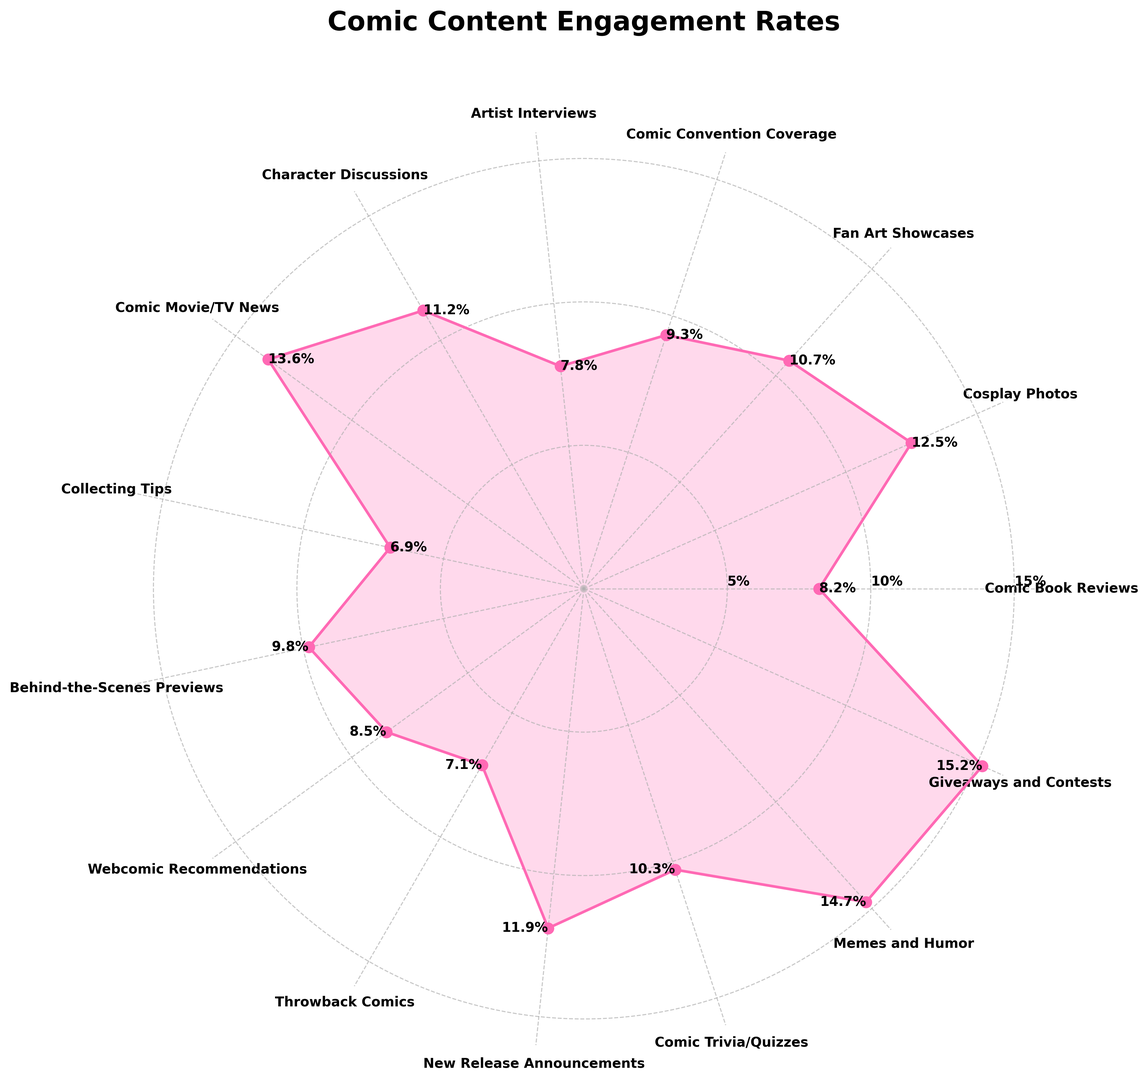Which type of comic-related content has the highest engagement rate? The figure shows various engagement rates, and the largest value on the plot represents the highest engagement rate. In this case, the "Giveaways and Contests" section extends furthest outward, indicating the highest rate.
Answer: Giveaways and Contests What is the difference in engagement rates between Memes and Humor and New Release Announcements? To find the difference, locate the engagement rates for "Memes and Humor" (14.7%) and "New Release Announcements" (11.9%) from the figure and subtract the latter from the former: 14.7% - 11.9% = 2.8%
Answer: 2.8% Which content type has the lowest engagement rate, and what is that rate? By examining the radial lengths on the plot, "Collecting Tips" is the shortest, which indicates the lowest engagement rate of 6.9%.
Answer: Collecting Tips, 6.9% How many content types have an engagement rate above 10%? Check each content type's engagement rate and count those above 10%. "Cosplay Photos," "Character Discussions," "Comic Movie/TV News," "New Release Announcements," "Comic Trivia/Quizzes," "Memes and Humor," and "Giveaways and Contests" have engagement rates above 10%.
Answer: 7 What is the total engagement rate for Fan Art Showcases, Comic Convention Coverage, and Behind-the-Scenes Previews? Sum the engagement rates for "Fan Art Showcases" (10.7%), "Comic Convention Coverage" (9.3%), and "Behind-the-Scenes Previews" (9.8%): 10.7% + 9.3% + 9.8% = 29.8%
Answer: 29.8% What is the average engagement rate for Character Discussions and Comic Movie/TV News? Find the engagement rates for "Character Discussions" (11.2%) and "Comic Movie/TV News" (13.6%), then calculate their average: (11.2% + 13.6%)/2 = 12.4%
Answer: 12.4% Are there more content types with engagement rates above 8% or below 8%? Count the number of content types with rates above 8% and those below 8%. "Comic Book Reviews," "Cosplay Photos," "Fan Art Showcases," "Comic Convention Coverage," "Character Discussions," "Comic Movie/TV News," "Behind-the-Scenes Previews," "Webcomic Recommendations," "New Release Announcements," "Comic Trivia/Quizzes," "Memes and Humor," and "Giveaways and Contests" have rates above 8%. "Artist Interviews," "Collecting Tips," and "Throwback Comics" have rates below 8%. Therefore, 12 content types are above 8%, while 3 are below 8%.
Answer: More above 8% Which content type is closer in engagement rate to Comic Book Reviews: Artist Interviews or Webcomic Recommendations? Compare the engagement rates: "Comic Book Reviews" is 8.2%. "Artist Interviews" is 7.8%, and "Webcomic Recommendations" is 8.5%. The difference between Comic Book Reviews and Artist Interviews is 8.2% - 7.8% = 0.4%, and the difference between Comic Book Reviews and Webcomic Recommendations is 8.5% - 8.2% = 0.3%.
Answer: Webcomic Recommendations 